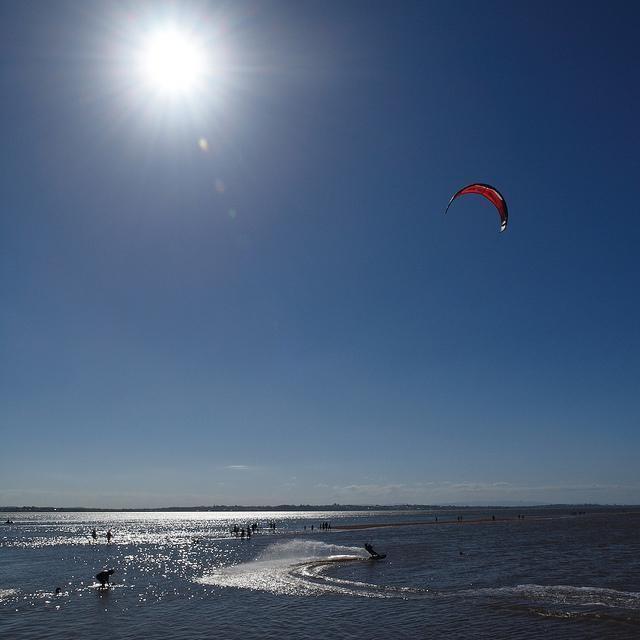What is the person with the kite doing?
Choose the correct response and explain in the format: 'Answer: answer
Rationale: rationale.'
Options: Flying, kite flying, sailing, kitesurfing. Answer: kitesurfing.
Rationale: A person is on the water on a surfboard attached to a kite. 